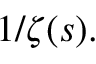<formula> <loc_0><loc_0><loc_500><loc_500>1 / \zeta ( s ) .</formula> 